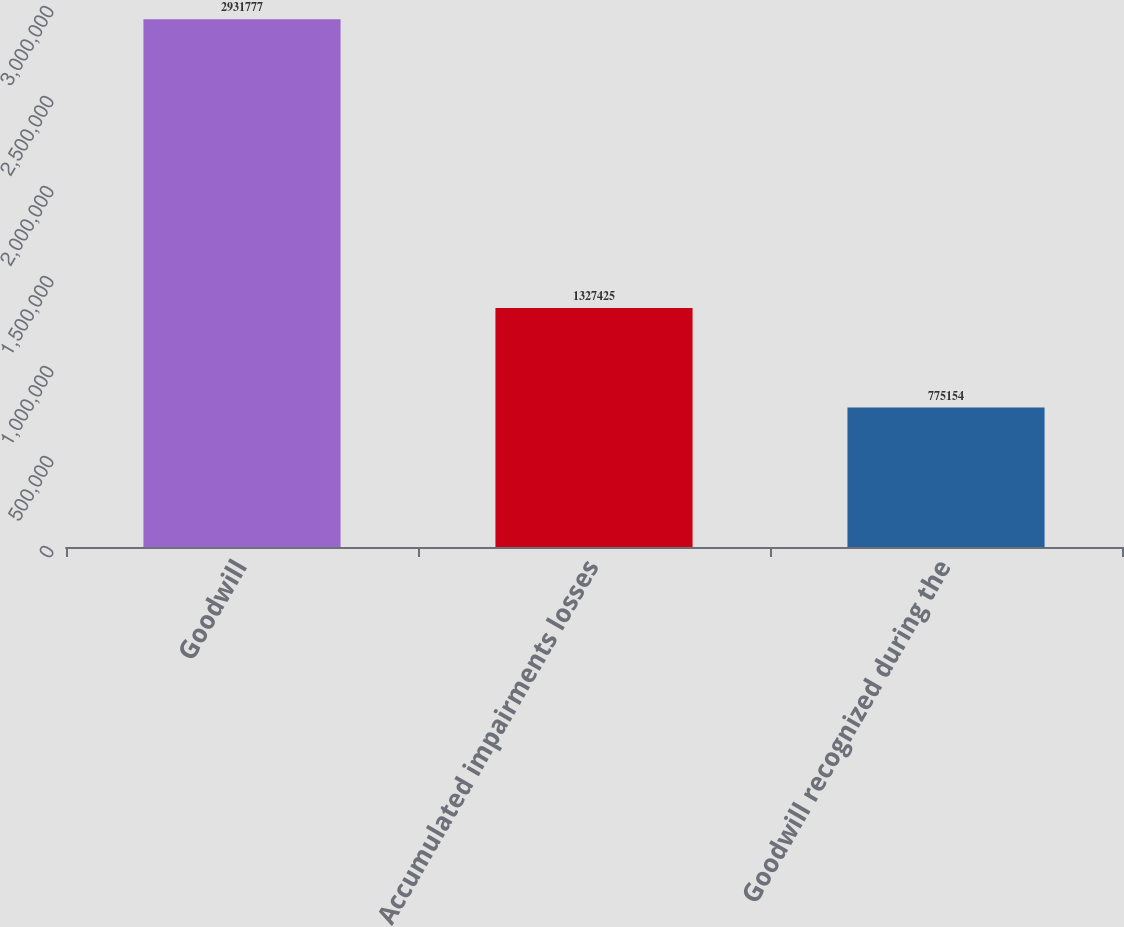Convert chart. <chart><loc_0><loc_0><loc_500><loc_500><bar_chart><fcel>Goodwill<fcel>Accumulated impairments losses<fcel>Goodwill recognized during the<nl><fcel>2.93178e+06<fcel>1.32742e+06<fcel>775154<nl></chart> 